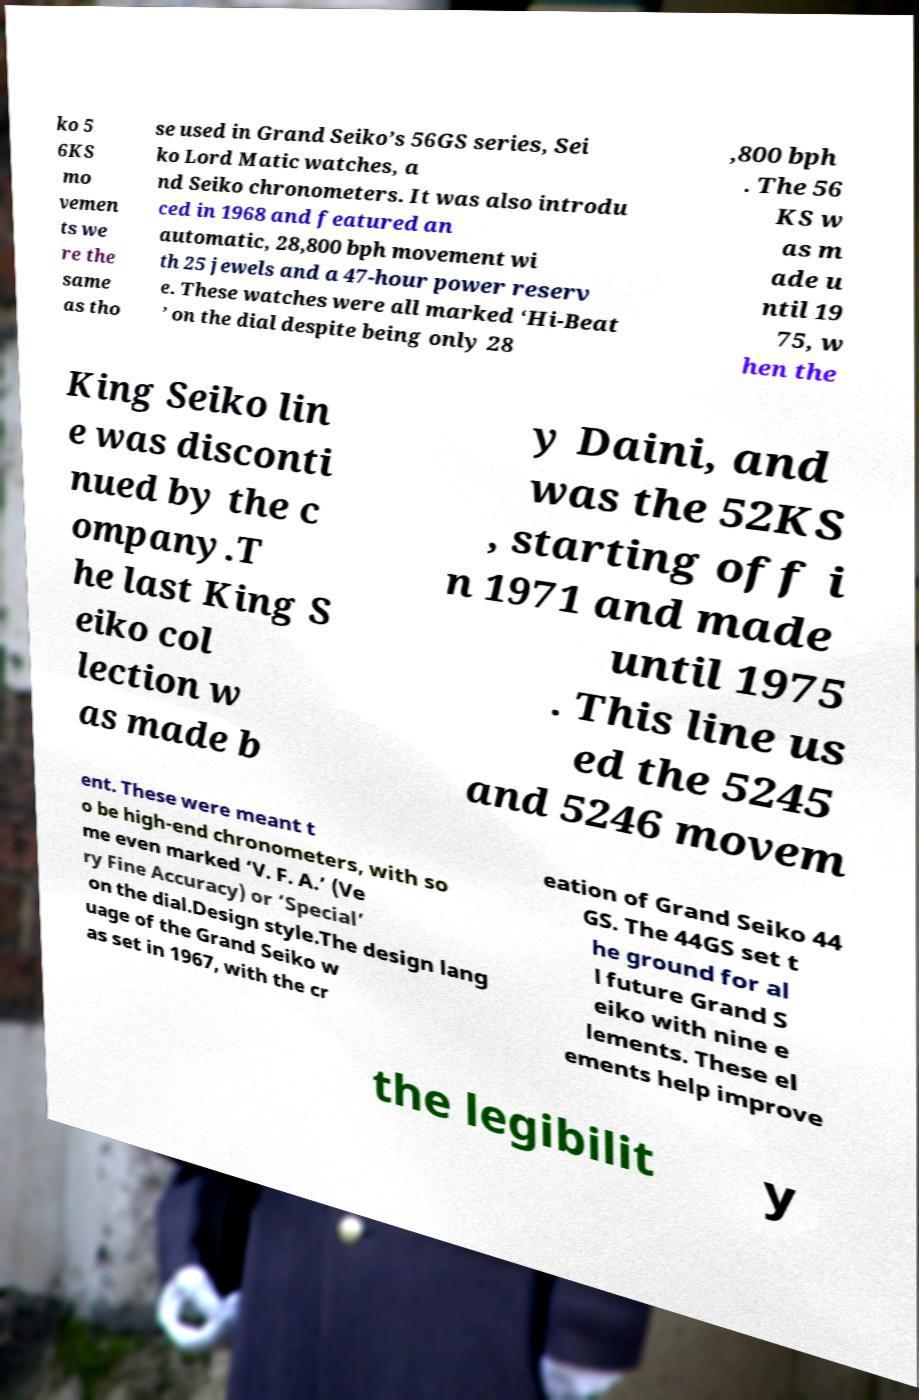What messages or text are displayed in this image? I need them in a readable, typed format. ko 5 6KS mo vemen ts we re the same as tho se used in Grand Seiko’s 56GS series, Sei ko Lord Matic watches, a nd Seiko chronometers. It was also introdu ced in 1968 and featured an automatic, 28,800 bph movement wi th 25 jewels and a 47-hour power reserv e. These watches were all marked ‘Hi-Beat ’ on the dial despite being only 28 ,800 bph . The 56 KS w as m ade u ntil 19 75, w hen the King Seiko lin e was disconti nued by the c ompany.T he last King S eiko col lection w as made b y Daini, and was the 52KS , starting off i n 1971 and made until 1975 . This line us ed the 5245 and 5246 movem ent. These were meant t o be high-end chronometers, with so me even marked ‘V. F. A.’ (Ve ry Fine Accuracy) or ‘Special’ on the dial.Design style.The design lang uage of the Grand Seiko w as set in 1967, with the cr eation of Grand Seiko 44 GS. The 44GS set t he ground for al l future Grand S eiko with nine e lements. These el ements help improve the legibilit y 